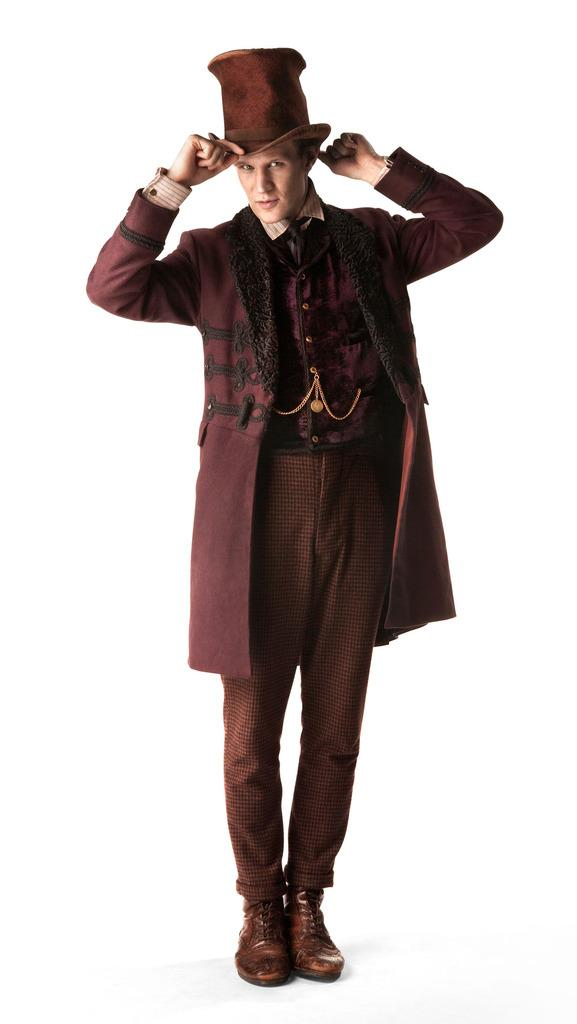Who or what is the main subject of the image? There is a person in the image. What is the person wearing on their upper body? The person is wearing a brown coat. What type of headwear is the person wearing? The person is wearing a hat. What color is the background of the image? The background of the image is white. What type of texture can be seen on the person's coat in the image? The provided facts do not mention the texture of the coat, so it cannot be determined from the image. 